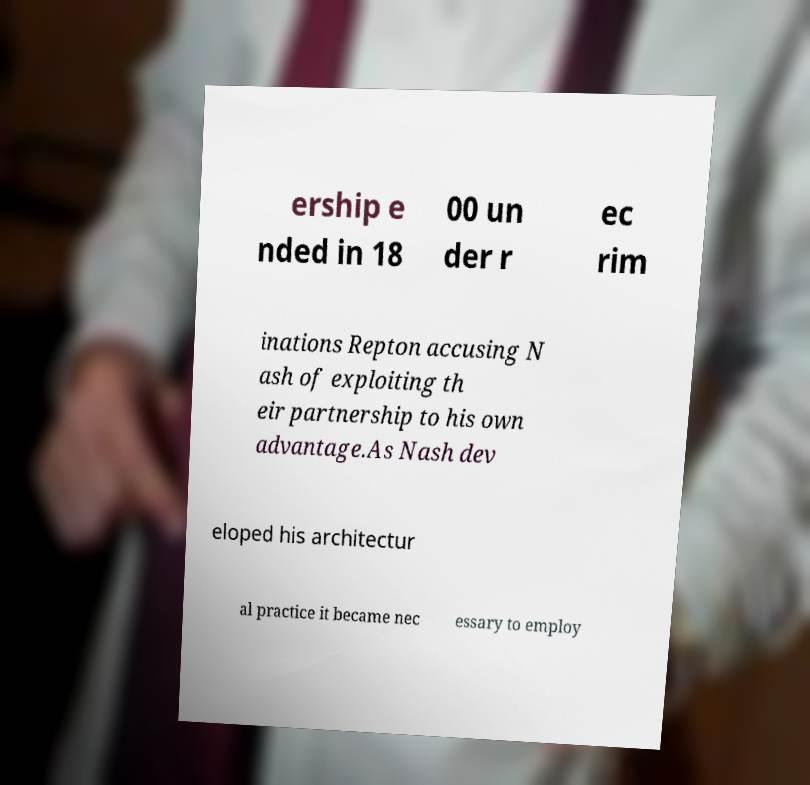For documentation purposes, I need the text within this image transcribed. Could you provide that? ership e nded in 18 00 un der r ec rim inations Repton accusing N ash of exploiting th eir partnership to his own advantage.As Nash dev eloped his architectur al practice it became nec essary to employ 